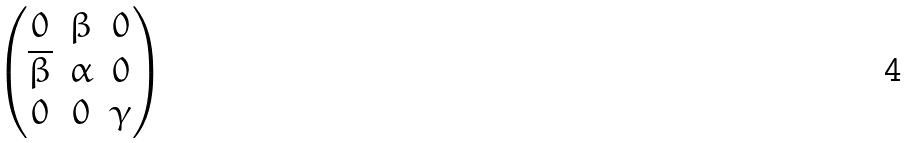Convert formula to latex. <formula><loc_0><loc_0><loc_500><loc_500>\begin{pmatrix} 0 & \beta & 0 \\ \overline { \beta } & \alpha & 0 \\ 0 & 0 & \gamma \end{pmatrix}</formula> 